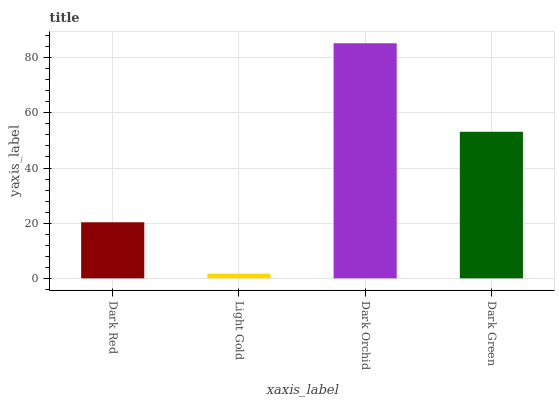Is Light Gold the minimum?
Answer yes or no. Yes. Is Dark Orchid the maximum?
Answer yes or no. Yes. Is Dark Orchid the minimum?
Answer yes or no. No. Is Light Gold the maximum?
Answer yes or no. No. Is Dark Orchid greater than Light Gold?
Answer yes or no. Yes. Is Light Gold less than Dark Orchid?
Answer yes or no. Yes. Is Light Gold greater than Dark Orchid?
Answer yes or no. No. Is Dark Orchid less than Light Gold?
Answer yes or no. No. Is Dark Green the high median?
Answer yes or no. Yes. Is Dark Red the low median?
Answer yes or no. Yes. Is Dark Red the high median?
Answer yes or no. No. Is Light Gold the low median?
Answer yes or no. No. 